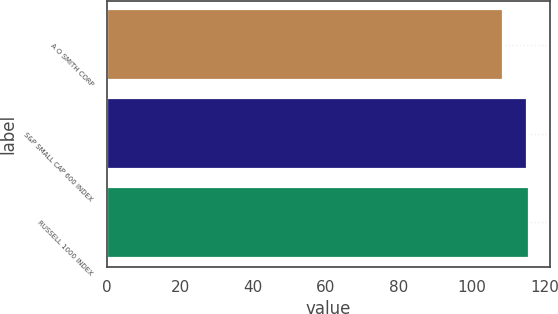Convert chart to OTSL. <chart><loc_0><loc_0><loc_500><loc_500><bar_chart><fcel>A O SMITH CORP<fcel>S&P SMALL CAP 600 INDEX<fcel>RUSSELL 1000 INDEX<nl><fcel>108.7<fcel>115.1<fcel>115.78<nl></chart> 